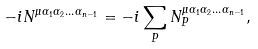<formula> <loc_0><loc_0><loc_500><loc_500>- i N ^ { \mu \alpha _ { 1 } \alpha _ { 2 } \dots \alpha _ { n - 1 } } = - i \sum _ { P } N ^ { \mu \alpha _ { 1 } \alpha _ { 2 } \dots \alpha _ { n - 1 } } _ { P } ,</formula> 